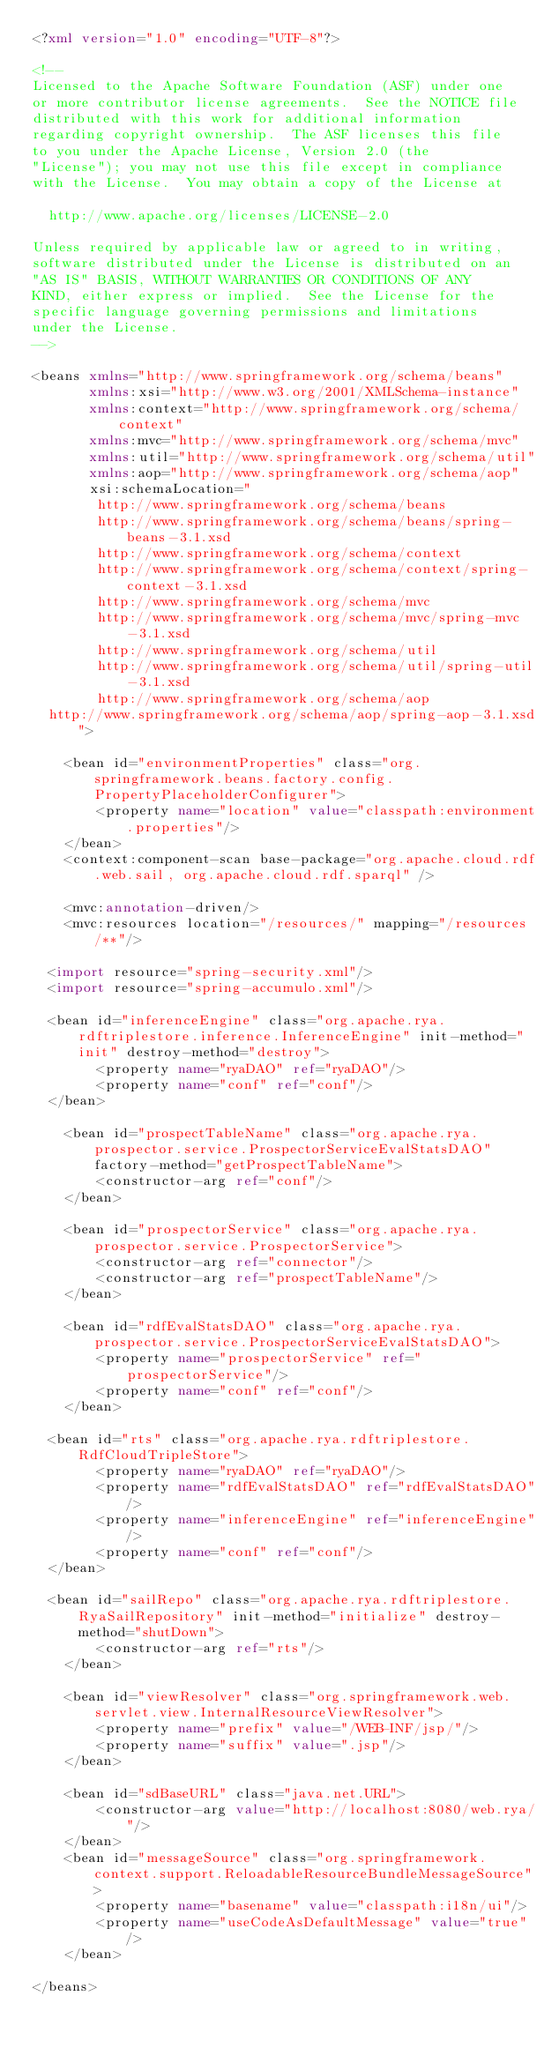<code> <loc_0><loc_0><loc_500><loc_500><_XML_><?xml version="1.0" encoding="UTF-8"?>

<!--
Licensed to the Apache Software Foundation (ASF) under one
or more contributor license agreements.  See the NOTICE file
distributed with this work for additional information
regarding copyright ownership.  The ASF licenses this file
to you under the Apache License, Version 2.0 (the
"License"); you may not use this file except in compliance
with the License.  You may obtain a copy of the License at

  http://www.apache.org/licenses/LICENSE-2.0

Unless required by applicable law or agreed to in writing,
software distributed under the License is distributed on an
"AS IS" BASIS, WITHOUT WARRANTIES OR CONDITIONS OF ANY
KIND, either express or implied.  See the License for the
specific language governing permissions and limitations
under the License.
-->

<beans xmlns="http://www.springframework.org/schema/beans"
       xmlns:xsi="http://www.w3.org/2001/XMLSchema-instance"
       xmlns:context="http://www.springframework.org/schema/context"
       xmlns:mvc="http://www.springframework.org/schema/mvc"
       xmlns:util="http://www.springframework.org/schema/util"
       xmlns:aop="http://www.springframework.org/schema/aop"
       xsi:schemaLocation="
        http://www.springframework.org/schema/beans
        http://www.springframework.org/schema/beans/spring-beans-3.1.xsd
        http://www.springframework.org/schema/context
        http://www.springframework.org/schema/context/spring-context-3.1.xsd
        http://www.springframework.org/schema/mvc
        http://www.springframework.org/schema/mvc/spring-mvc-3.1.xsd
        http://www.springframework.org/schema/util
        http://www.springframework.org/schema/util/spring-util-3.1.xsd
        http://www.springframework.org/schema/aop 
	http://www.springframework.org/schema/aop/spring-aop-3.1.xsd">

    <bean id="environmentProperties" class="org.springframework.beans.factory.config.PropertyPlaceholderConfigurer">
        <property name="location" value="classpath:environment.properties"/>
    </bean>
    <context:component-scan base-package="org.apache.cloud.rdf.web.sail, org.apache.cloud.rdf.sparql" />

    <mvc:annotation-driven/>
    <mvc:resources location="/resources/" mapping="/resources/**"/>

	<import resource="spring-security.xml"/>	
	<import resource="spring-accumulo.xml"/>

	<bean id="inferenceEngine" class="org.apache.rya.rdftriplestore.inference.InferenceEngine" init-method="init" destroy-method="destroy">
        <property name="ryaDAO" ref="ryaDAO"/>
        <property name="conf" ref="conf"/>
	</bean>
    
    <bean id="prospectTableName" class="org.apache.rya.prospector.service.ProspectorServiceEvalStatsDAO" factory-method="getProspectTableName">
        <constructor-arg ref="conf"/>
    </bean>
    
    <bean id="prospectorService" class="org.apache.rya.prospector.service.ProspectorService">
        <constructor-arg ref="connector"/>
        <constructor-arg ref="prospectTableName"/>
    </bean>
    
    <bean id="rdfEvalStatsDAO" class="org.apache.rya.prospector.service.ProspectorServiceEvalStatsDAO">
        <property name="prospectorService" ref="prospectorService"/>
        <property name="conf" ref="conf"/>
    </bean>

	<bean id="rts" class="org.apache.rya.rdftriplestore.RdfCloudTripleStore">
        <property name="ryaDAO" ref="ryaDAO"/>
        <property name="rdfEvalStatsDAO" ref="rdfEvalStatsDAO"/>
        <property name="inferenceEngine" ref="inferenceEngine"/>
        <property name="conf" ref="conf"/>
	</bean>

	<bean id="sailRepo" class="org.apache.rya.rdftriplestore.RyaSailRepository" init-method="initialize" destroy-method="shutDown">
        <constructor-arg ref="rts"/>
    </bean>

    <bean id="viewResolver" class="org.springframework.web.servlet.view.InternalResourceViewResolver">
        <property name="prefix" value="/WEB-INF/jsp/"/>
        <property name="suffix" value=".jsp"/>
    </bean>

    <bean id="sdBaseURL" class="java.net.URL">
        <constructor-arg value="http://localhost:8080/web.rya/"/>
    </bean>
    <bean id="messageSource" class="org.springframework.context.support.ReloadableResourceBundleMessageSource">
        <property name="basename" value="classpath:i18n/ui"/>
        <property name="useCodeAsDefaultMessage" value="true"/>
    </bean>

</beans>
</code> 